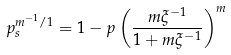<formula> <loc_0><loc_0><loc_500><loc_500>p _ { s } ^ { m ^ { - 1 } / 1 } = 1 - p \left ( \frac { m \xi ^ { - 1 } } { 1 + m \xi ^ { - 1 } } \right ) ^ { m } \,</formula> 